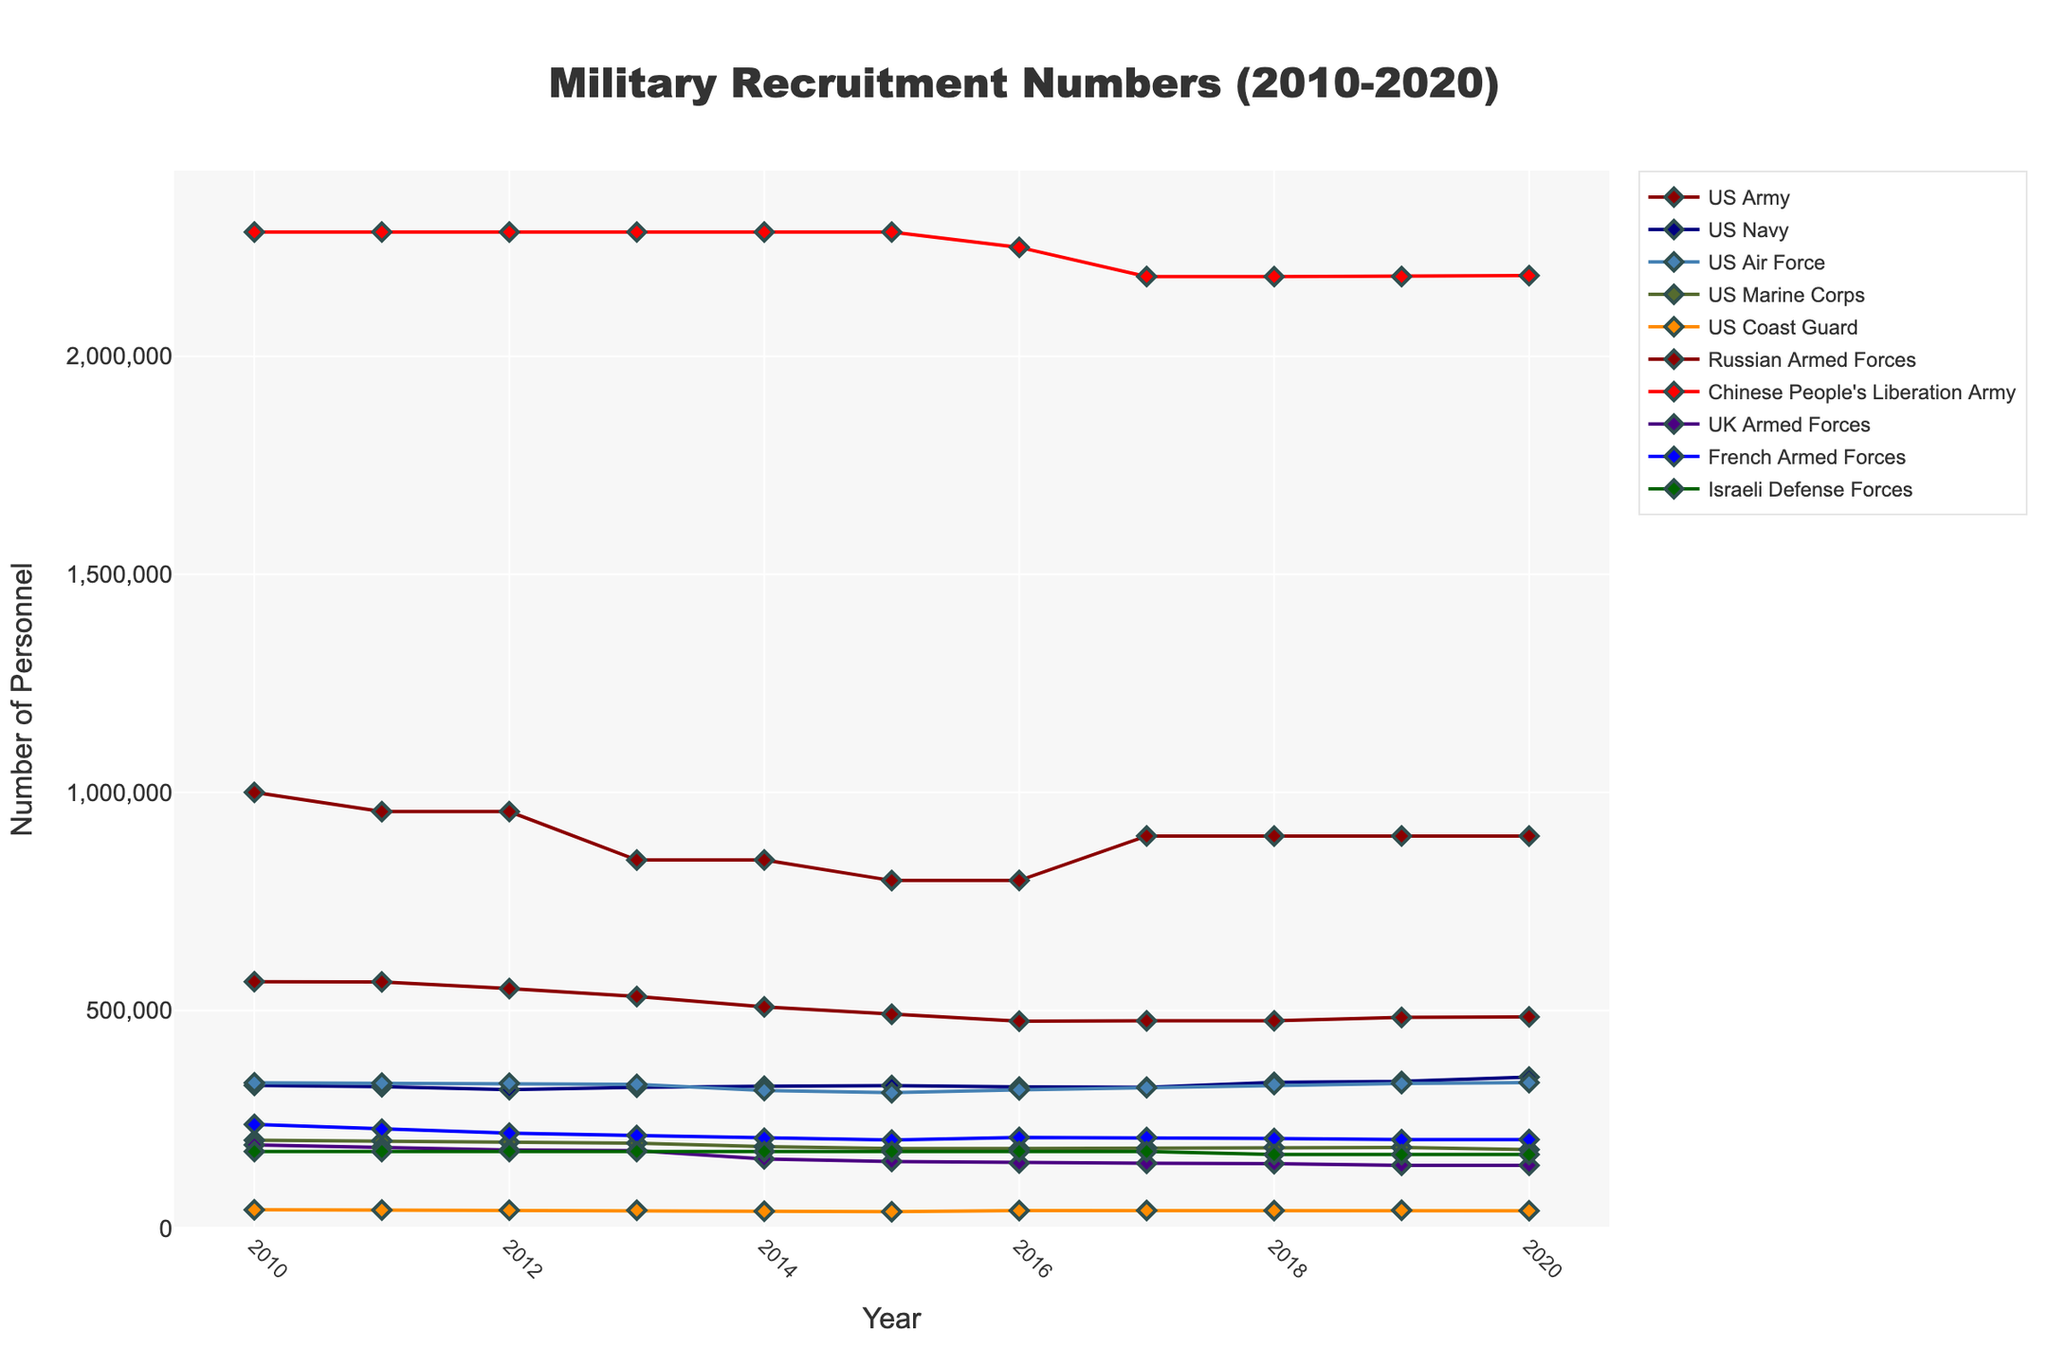What's the recruitment trend for the US Army from 2010 to 2020? To determine the trend, observe the line representing the US Army's recruitment numbers on the line chart from 2010 to 2020. Note the changes in the numbers, which generally exhibit a decline from 566,045 in 2010 to approximately 485,383 in 2020.
Answer: Decline Which branch had the highest recruitment number in 2020? Look for the branch with the highest position on the y-axis in 2020. The Chinese People's Liberation Army had the largest number of personnel in 2020.
Answer: Chinese People's Liberation Army What is the difference in recruitment numbers between the Russian Armed Forces and the UK Armed Forces in 2014? Find the recruitment numbers for both the Russian Armed Forces (845,000) and the UK Armed Forces (159,630) in 2014. Subtract the latter from the former (845,000 - 159,630).
Answer: 685,370 Which branches saw an increase in recruitment numbers from 2015 to 2020? Compare the recruitment numbers for 2015 and 2020 for each branch. The US Navy (327,801 to 347,162), US Air Force (311,357 to 334,371), Russian Armed Forces (798,000 to 900,000), and Chinese People's Liberation Army (2250000 to 2185000) increased.
Answer: US Navy, US Air Force, Russian Armed Forces, Chinese People's Liberation Army By how much did the US Navy's recruitment number increase from 2017 to 2018? Determine the recruitment numbers for the US Navy in 2017 (323,933) and 2018 (335,212). Calculate the difference (335,212 - 323,933).
Answer: 11,279 Which branch had the most stable recruitment numbers from 2010 to 2020? Assess the variability of line traces for each branch. The Israeli Defense Forces line shows no fluctuation, maintaining constant values at 176,500 (except for a slight dip in 2018 and 2019 where it was 169,500).
Answer: Israeli Defense Forces How did the recruitment number for the French Armed Forces change from 2016 to 2020? Compare the recruitment numbers of the French Armed Forces in 2016 (208,950) and in 2020 (203,900). It shows a slight decrease (208,950 - 203,900).
Answer: Decrease Which branch's recruitment number dipped below 200,000 in 2014? Observe all the line traces for any branch dipping below the 200,000 mark on the y-axis in 2014. The UK Armed Forces dipped below 200,000 to 159,630 in 2014.
Answer: UK Armed Forces What is the average recruitment number for the US Marine Corps over the entire time period from 2010 to 2020? Sum the recruitment numbers for the US Marine Corps from 2010 to 2020 (202,441 + 201,157 + 198,193 + 195,848 + 187,891 + 183,417 + 183,501 + 184,401 + 186,009 + 186,009 + 180,958) and divide by 11. The calculation gives an average of approximately 190,002.
Answer: 190,002 Which year did the US Coast Guard show the lowest recruitment number? Scan the line representing the US Coast Guard and find the point where it touches the lowest y-value. In 2014, the US Coast Guard had the lowest recruitment number at 39,454.
Answer: 2014 